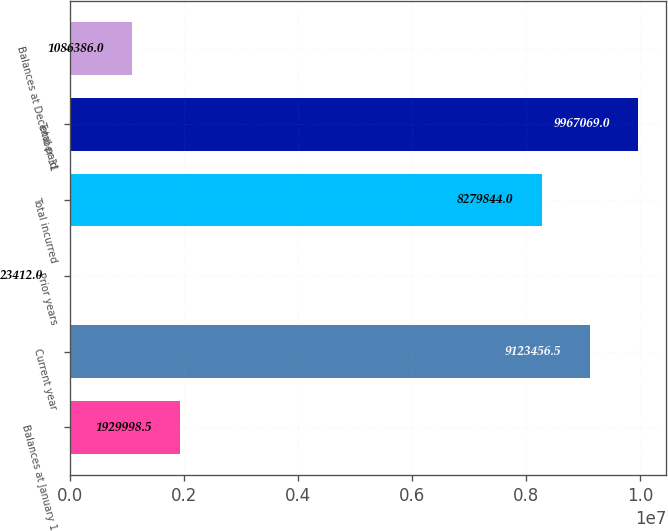Convert chart to OTSL. <chart><loc_0><loc_0><loc_500><loc_500><bar_chart><fcel>Balances at January 1<fcel>Current year<fcel>Prior years<fcel>Total incurred<fcel>Total paid<fcel>Balances at December 31<nl><fcel>1.93e+06<fcel>9.12346e+06<fcel>23412<fcel>8.27984e+06<fcel>9.96707e+06<fcel>1.08639e+06<nl></chart> 